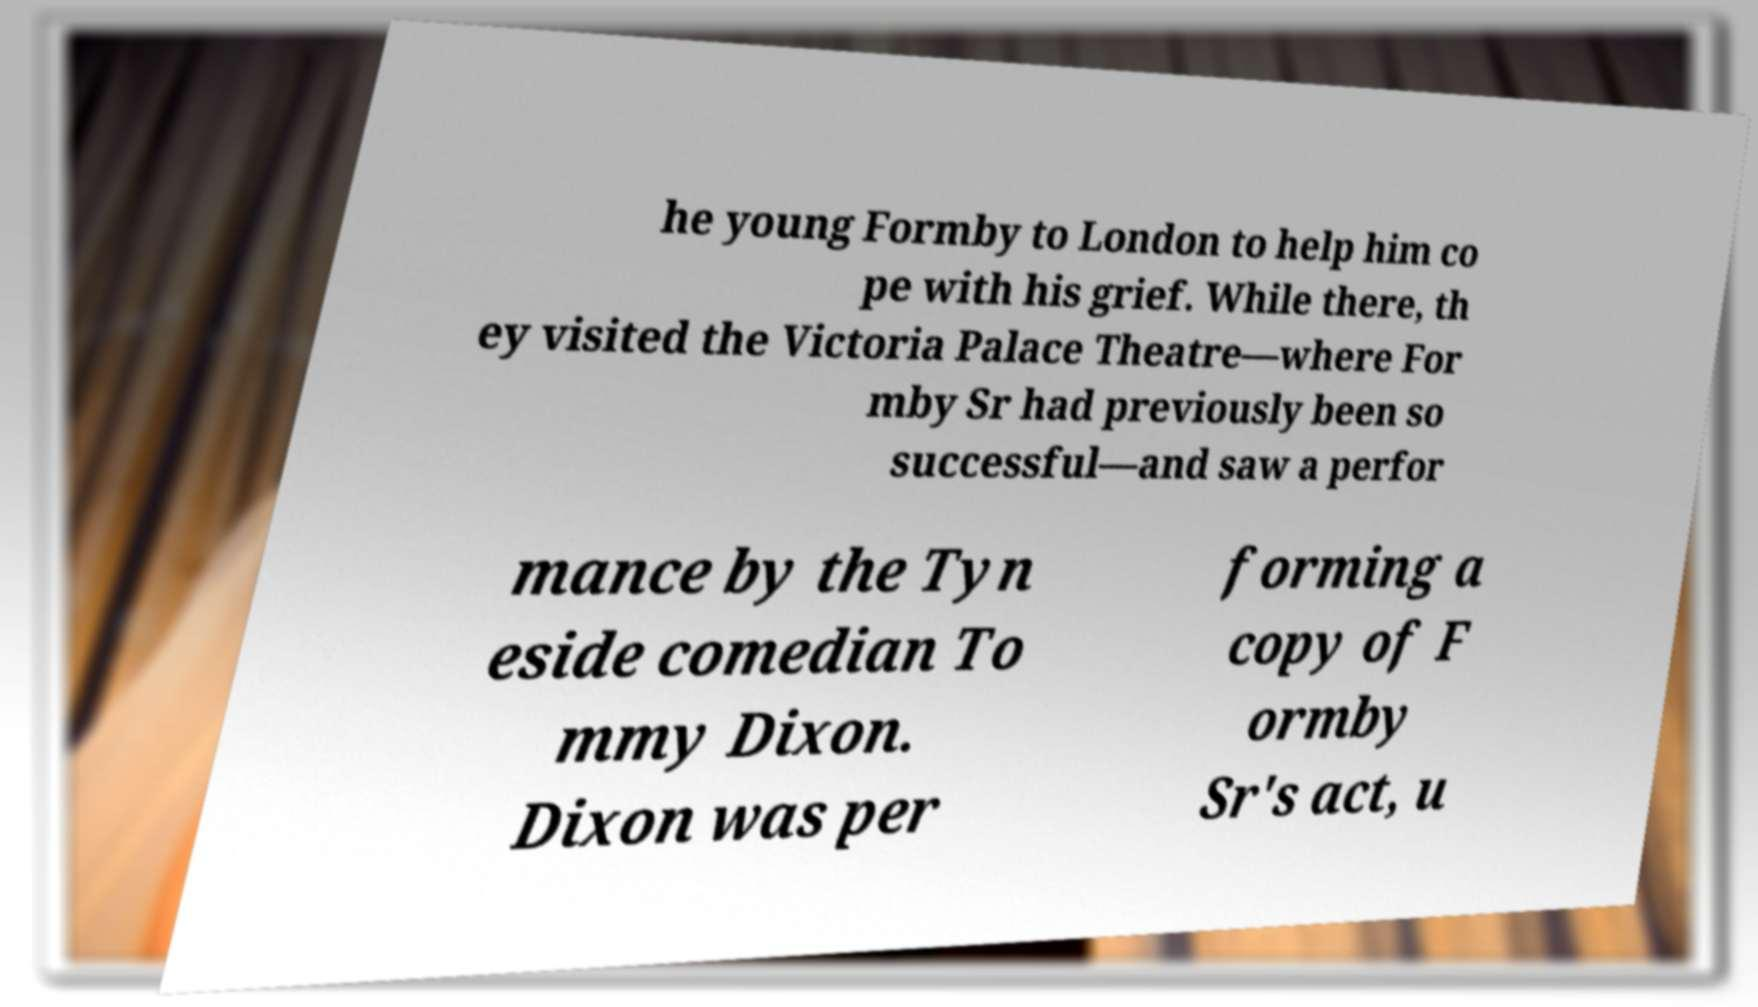Can you read and provide the text displayed in the image?This photo seems to have some interesting text. Can you extract and type it out for me? he young Formby to London to help him co pe with his grief. While there, th ey visited the Victoria Palace Theatre—where For mby Sr had previously been so successful—and saw a perfor mance by the Tyn eside comedian To mmy Dixon. Dixon was per forming a copy of F ormby Sr's act, u 